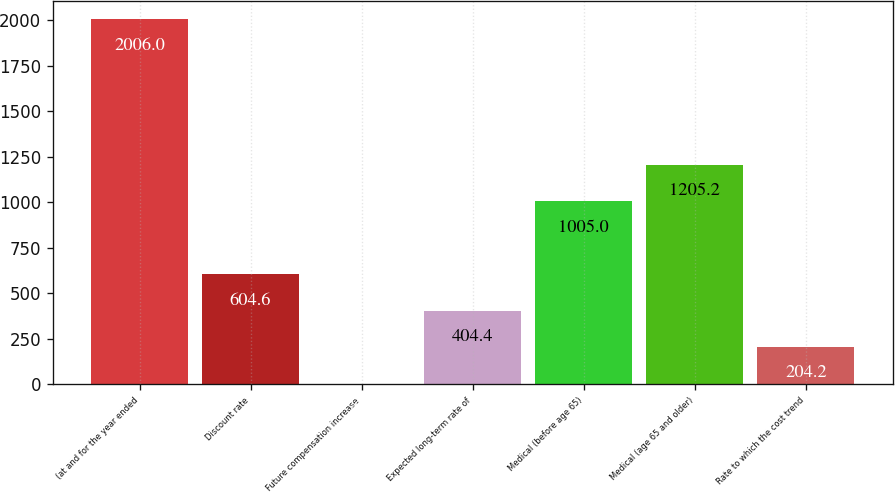Convert chart. <chart><loc_0><loc_0><loc_500><loc_500><bar_chart><fcel>(at and for the year ended<fcel>Discount rate<fcel>Future compensation increase<fcel>Expected long-term rate of<fcel>Medical (before age 65)<fcel>Medical (age 65 and older)<fcel>Rate to which the cost trend<nl><fcel>2006<fcel>604.6<fcel>4<fcel>404.4<fcel>1005<fcel>1205.2<fcel>204.2<nl></chart> 